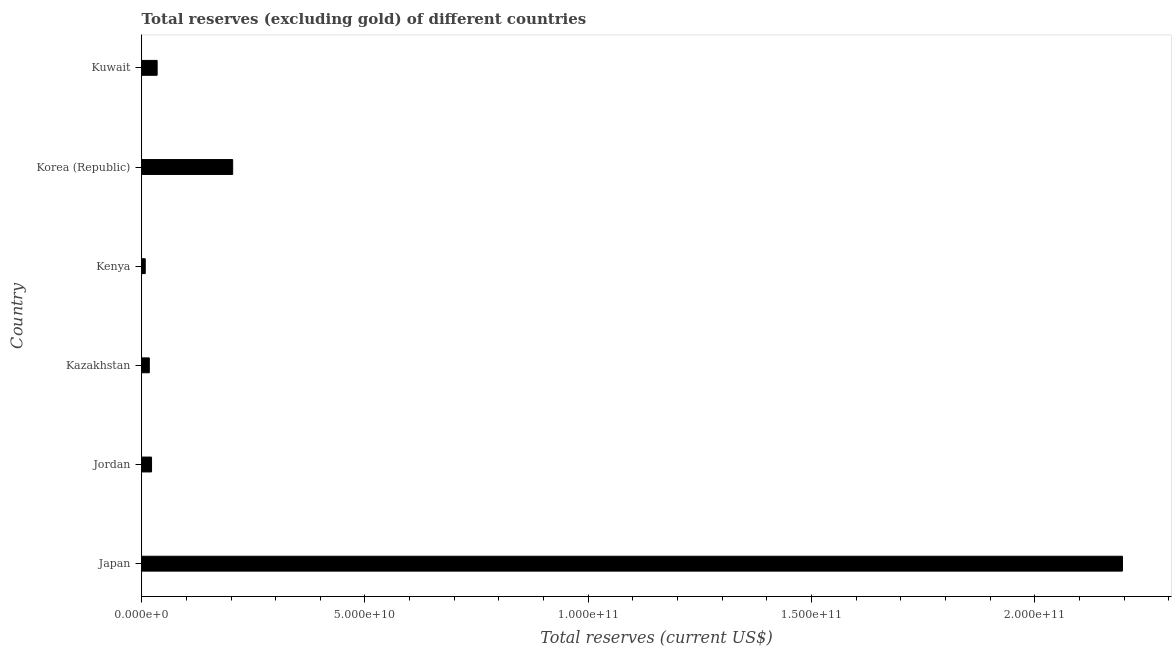What is the title of the graph?
Your response must be concise. Total reserves (excluding gold) of different countries. What is the label or title of the X-axis?
Give a very brief answer. Total reserves (current US$). What is the total reserves (excluding gold) in Jordan?
Give a very brief answer. 2.20e+09. Across all countries, what is the maximum total reserves (excluding gold)?
Offer a terse response. 2.20e+11. Across all countries, what is the minimum total reserves (excluding gold)?
Provide a succinct answer. 7.88e+08. In which country was the total reserves (excluding gold) maximum?
Ensure brevity in your answer.  Japan. In which country was the total reserves (excluding gold) minimum?
Your answer should be very brief. Kenya. What is the sum of the total reserves (excluding gold)?
Keep it short and to the point. 2.48e+11. What is the difference between the total reserves (excluding gold) in Jordan and Korea (Republic)?
Make the answer very short. -1.82e+1. What is the average total reserves (excluding gold) per country?
Keep it short and to the point. 4.14e+1. What is the median total reserves (excluding gold)?
Your answer should be compact. 2.83e+09. In how many countries, is the total reserves (excluding gold) greater than 80000000000 US$?
Provide a short and direct response. 1. What is the ratio of the total reserves (excluding gold) in Kazakhstan to that in Kuwait?
Make the answer very short. 0.49. What is the difference between the highest and the second highest total reserves (excluding gold)?
Make the answer very short. 1.99e+11. Is the sum of the total reserves (excluding gold) in Jordan and Kazakhstan greater than the maximum total reserves (excluding gold) across all countries?
Your response must be concise. No. What is the difference between the highest and the lowest total reserves (excluding gold)?
Ensure brevity in your answer.  2.19e+11. In how many countries, is the total reserves (excluding gold) greater than the average total reserves (excluding gold) taken over all countries?
Offer a very short reply. 1. Are all the bars in the graph horizontal?
Your response must be concise. Yes. What is the difference between two consecutive major ticks on the X-axis?
Your answer should be compact. 5.00e+1. Are the values on the major ticks of X-axis written in scientific E-notation?
Provide a succinct answer. Yes. What is the Total reserves (current US$) in Japan?
Your response must be concise. 2.20e+11. What is the Total reserves (current US$) in Jordan?
Offer a terse response. 2.20e+09. What is the Total reserves (current US$) in Kazakhstan?
Offer a very short reply. 1.70e+09. What is the Total reserves (current US$) of Kenya?
Keep it short and to the point. 7.88e+08. What is the Total reserves (current US$) of Korea (Republic)?
Provide a short and direct response. 2.04e+1. What is the Total reserves (current US$) in Kuwait?
Keep it short and to the point. 3.45e+09. What is the difference between the Total reserves (current US$) in Japan and Jordan?
Your response must be concise. 2.17e+11. What is the difference between the Total reserves (current US$) in Japan and Kazakhstan?
Ensure brevity in your answer.  2.18e+11. What is the difference between the Total reserves (current US$) in Japan and Kenya?
Offer a terse response. 2.19e+11. What is the difference between the Total reserves (current US$) in Japan and Korea (Republic)?
Provide a succinct answer. 1.99e+11. What is the difference between the Total reserves (current US$) in Japan and Kuwait?
Provide a short and direct response. 2.16e+11. What is the difference between the Total reserves (current US$) in Jordan and Kazakhstan?
Ensure brevity in your answer.  5.03e+08. What is the difference between the Total reserves (current US$) in Jordan and Kenya?
Your answer should be compact. 1.41e+09. What is the difference between the Total reserves (current US$) in Jordan and Korea (Republic)?
Give a very brief answer. -1.82e+1. What is the difference between the Total reserves (current US$) in Jordan and Kuwait?
Provide a short and direct response. -1.25e+09. What is the difference between the Total reserves (current US$) in Kazakhstan and Kenya?
Offer a very short reply. 9.09e+08. What is the difference between the Total reserves (current US$) in Kazakhstan and Korea (Republic)?
Offer a terse response. -1.87e+1. What is the difference between the Total reserves (current US$) in Kazakhstan and Kuwait?
Provide a short and direct response. -1.75e+09. What is the difference between the Total reserves (current US$) in Kenya and Korea (Republic)?
Provide a short and direct response. -1.96e+1. What is the difference between the Total reserves (current US$) in Kenya and Kuwait?
Offer a terse response. -2.66e+09. What is the difference between the Total reserves (current US$) in Korea (Republic) and Kuwait?
Your answer should be compact. 1.69e+1. What is the ratio of the Total reserves (current US$) in Japan to that in Jordan?
Keep it short and to the point. 99.83. What is the ratio of the Total reserves (current US$) in Japan to that in Kazakhstan?
Provide a short and direct response. 129.42. What is the ratio of the Total reserves (current US$) in Japan to that in Kenya?
Keep it short and to the point. 278.76. What is the ratio of the Total reserves (current US$) in Japan to that in Korea (Republic)?
Give a very brief answer. 10.78. What is the ratio of the Total reserves (current US$) in Japan to that in Kuwait?
Make the answer very short. 63.63. What is the ratio of the Total reserves (current US$) in Jordan to that in Kazakhstan?
Offer a terse response. 1.3. What is the ratio of the Total reserves (current US$) in Jordan to that in Kenya?
Your answer should be compact. 2.79. What is the ratio of the Total reserves (current US$) in Jordan to that in Korea (Republic)?
Ensure brevity in your answer.  0.11. What is the ratio of the Total reserves (current US$) in Jordan to that in Kuwait?
Provide a short and direct response. 0.64. What is the ratio of the Total reserves (current US$) in Kazakhstan to that in Kenya?
Provide a short and direct response. 2.15. What is the ratio of the Total reserves (current US$) in Kazakhstan to that in Korea (Republic)?
Your answer should be very brief. 0.08. What is the ratio of the Total reserves (current US$) in Kazakhstan to that in Kuwait?
Give a very brief answer. 0.49. What is the ratio of the Total reserves (current US$) in Kenya to that in Korea (Republic)?
Provide a short and direct response. 0.04. What is the ratio of the Total reserves (current US$) in Kenya to that in Kuwait?
Your answer should be compact. 0.23. What is the ratio of the Total reserves (current US$) in Korea (Republic) to that in Kuwait?
Provide a succinct answer. 5.9. 